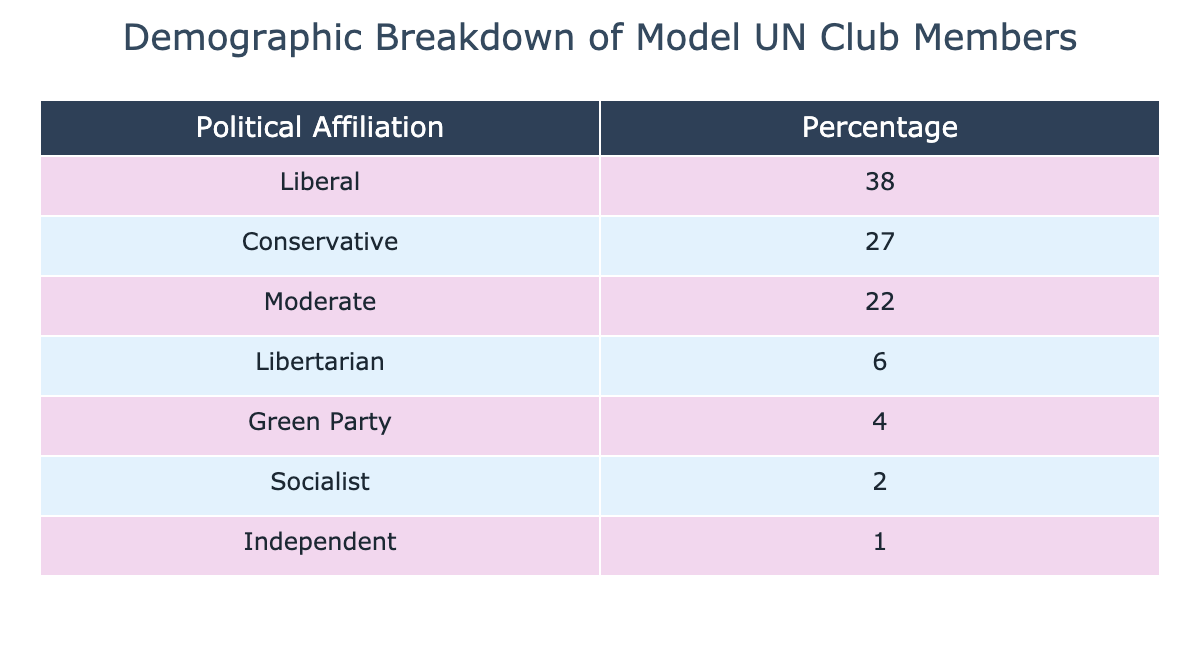What is the percentage of Liberal members in the club? The table explicitly states the percentage of members who identify as Liberal. By checking the row for Liberal, we see that the corresponding percentage is 38.
Answer: 38 What is the total percentage of Conservative and Moderate members combined? To find the combined percentage of Conservative and Moderate members, we add the percentages for both groups. Conservative is 27 and Moderate is 22. Thus, the total is 27 + 22 = 49.
Answer: 49 Is the percentage of Green Party members greater than that of Socialist members? The table shows the percentage for Green Party members as 4 and Socialist members as 2. Comparing these, we find that 4 is greater than 2.
Answer: Yes What is the difference in percentage between Conservative and Liberal members? The percentage of Conservative members is 27 and the percentage of Liberal members is 38. To find the difference, we subtract Conservative from Liberal: 38 - 27 = 11.
Answer: 11 What percentage of the members identify as either Libertarian or Green Party? We find the percentages for both Libertarian (6) and Green Party (4) and add them together: 6 + 4 = 10. Thus, the total percentage for either group is 10.
Answer: 10 Is there a higher percentage of Independents than Socialists in the club? The table indicates 1% for Independents and 2% for Socialists. Since 1 is not greater than 2, the answer is no.
Answer: No What percentage of club members does not identify as Liberal? To find this, we can take 100% (the total) and subtract the percentage of Liberal members, which is 38. So, 100 - 38 = 62.
Answer: 62 How many political affiliations are represented in the table? By counting the rows in the table, we see there are a total of 7 different political affiliations represented.
Answer: 7 What political affiliation has the lowest membership percentage? From the table, we check each percentage and identify that Independent has the lowest percentage at 1.
Answer: Independent 